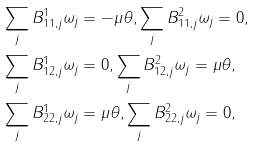Convert formula to latex. <formula><loc_0><loc_0><loc_500><loc_500>& \sum _ { j } B ^ { 1 } _ { 1 1 , j } \omega _ { j } = - \mu \theta , \sum _ { j } B ^ { 2 } _ { 1 1 , j } \omega _ { j } = 0 , \\ & \sum _ { j } B ^ { 1 } _ { 1 2 , j } \omega _ { j } = 0 , \sum _ { j } B ^ { 2 } _ { 1 2 , j } \omega _ { j } = \mu \theta , \\ & \sum _ { j } B ^ { 1 } _ { 2 2 , j } \omega _ { j } = \mu \theta , \sum _ { j } B ^ { 2 } _ { 2 2 , j } \omega _ { j } = 0 ,</formula> 